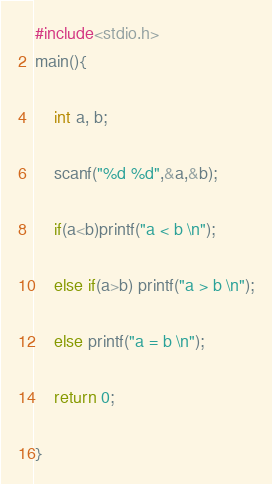<code> <loc_0><loc_0><loc_500><loc_500><_C_>#include<stdio.h>
main(){

    int a, b;

    scanf("%d %d",&a,&b);

    if(a<b)printf("a < b \n");

    else if(a>b) printf("a > b \n");

    else printf("a = b \n");

    return 0;

}

</code> 